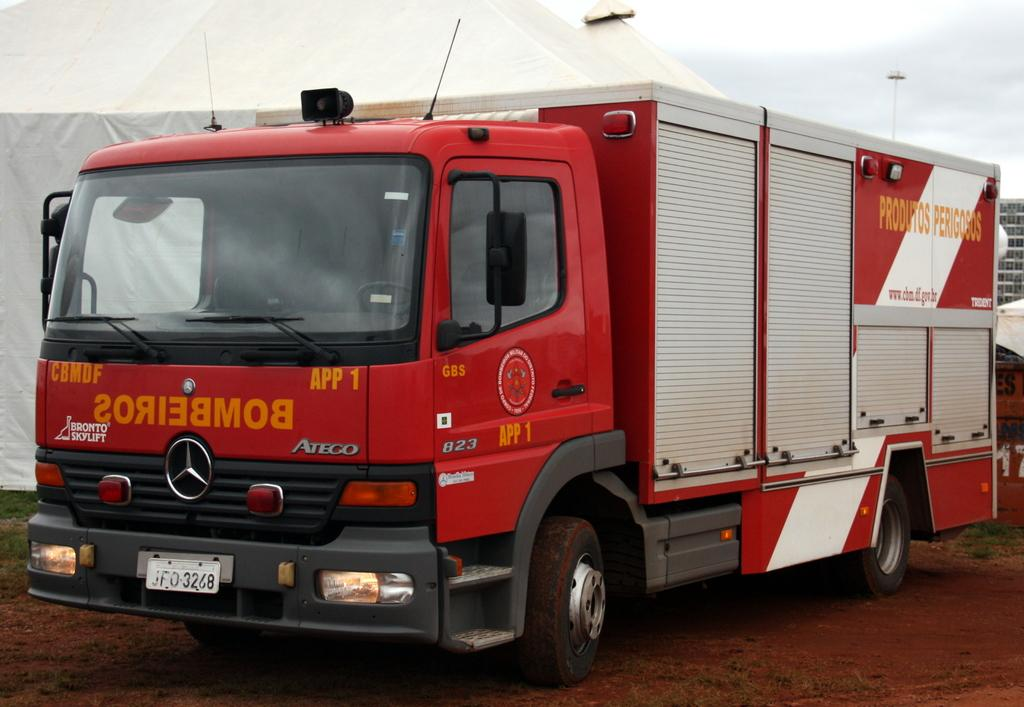What is the main subject of the image? The main subject of the image is a truck. What is located behind the truck in the image? There is a tent behind the truck. What structure is visible on the right corner of the image? There is a building on the right corner of the image. What can be seen in the background of the image? The sky is visible in the background of the image. What type of fan is being used to cool down the cow in the image? There is no cow or fan present in the image. 